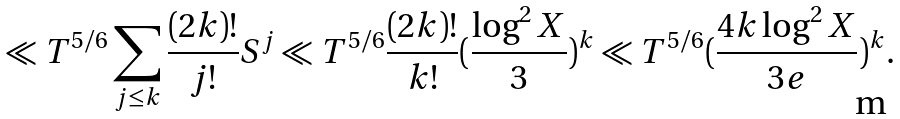<formula> <loc_0><loc_0><loc_500><loc_500>\ll T ^ { 5 / 6 } \sum _ { j \leq k } \frac { ( 2 k ) ! } { j ! } S ^ { j } \ll T ^ { 5 / 6 } \frac { ( 2 k ) ! } { k ! } ( \frac { \log ^ { 2 } X } { 3 } ) ^ { k } \ll T ^ { 5 / 6 } ( \frac { 4 k \log ^ { 2 } X } { 3 e } ) ^ { k } .</formula> 